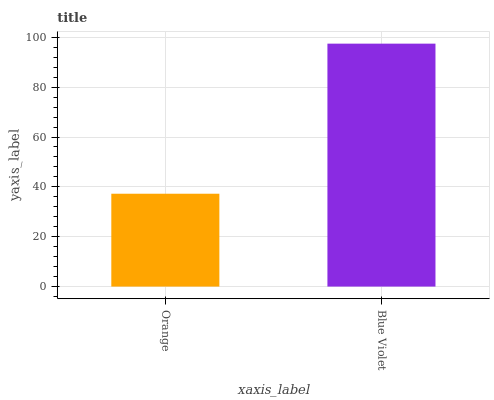Is Orange the minimum?
Answer yes or no. Yes. Is Blue Violet the maximum?
Answer yes or no. Yes. Is Blue Violet the minimum?
Answer yes or no. No. Is Blue Violet greater than Orange?
Answer yes or no. Yes. Is Orange less than Blue Violet?
Answer yes or no. Yes. Is Orange greater than Blue Violet?
Answer yes or no. No. Is Blue Violet less than Orange?
Answer yes or no. No. Is Blue Violet the high median?
Answer yes or no. Yes. Is Orange the low median?
Answer yes or no. Yes. Is Orange the high median?
Answer yes or no. No. Is Blue Violet the low median?
Answer yes or no. No. 